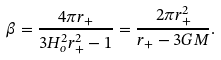Convert formula to latex. <formula><loc_0><loc_0><loc_500><loc_500>\beta = \frac { 4 \pi r _ { + } } { 3 H _ { o } ^ { 2 } r _ { + } ^ { 2 } - 1 } = \frac { 2 \pi r _ { + } ^ { 2 } } { r _ { + } - 3 G M } .</formula> 